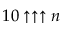Convert formula to latex. <formula><loc_0><loc_0><loc_500><loc_500>1 0 \uparrow \uparrow \uparrow n</formula> 